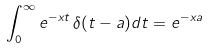Convert formula to latex. <formula><loc_0><loc_0><loc_500><loc_500>\int _ { 0 } ^ { \infty } e ^ { - x t } \, \delta ( t - a ) d t & = e ^ { - x a }</formula> 